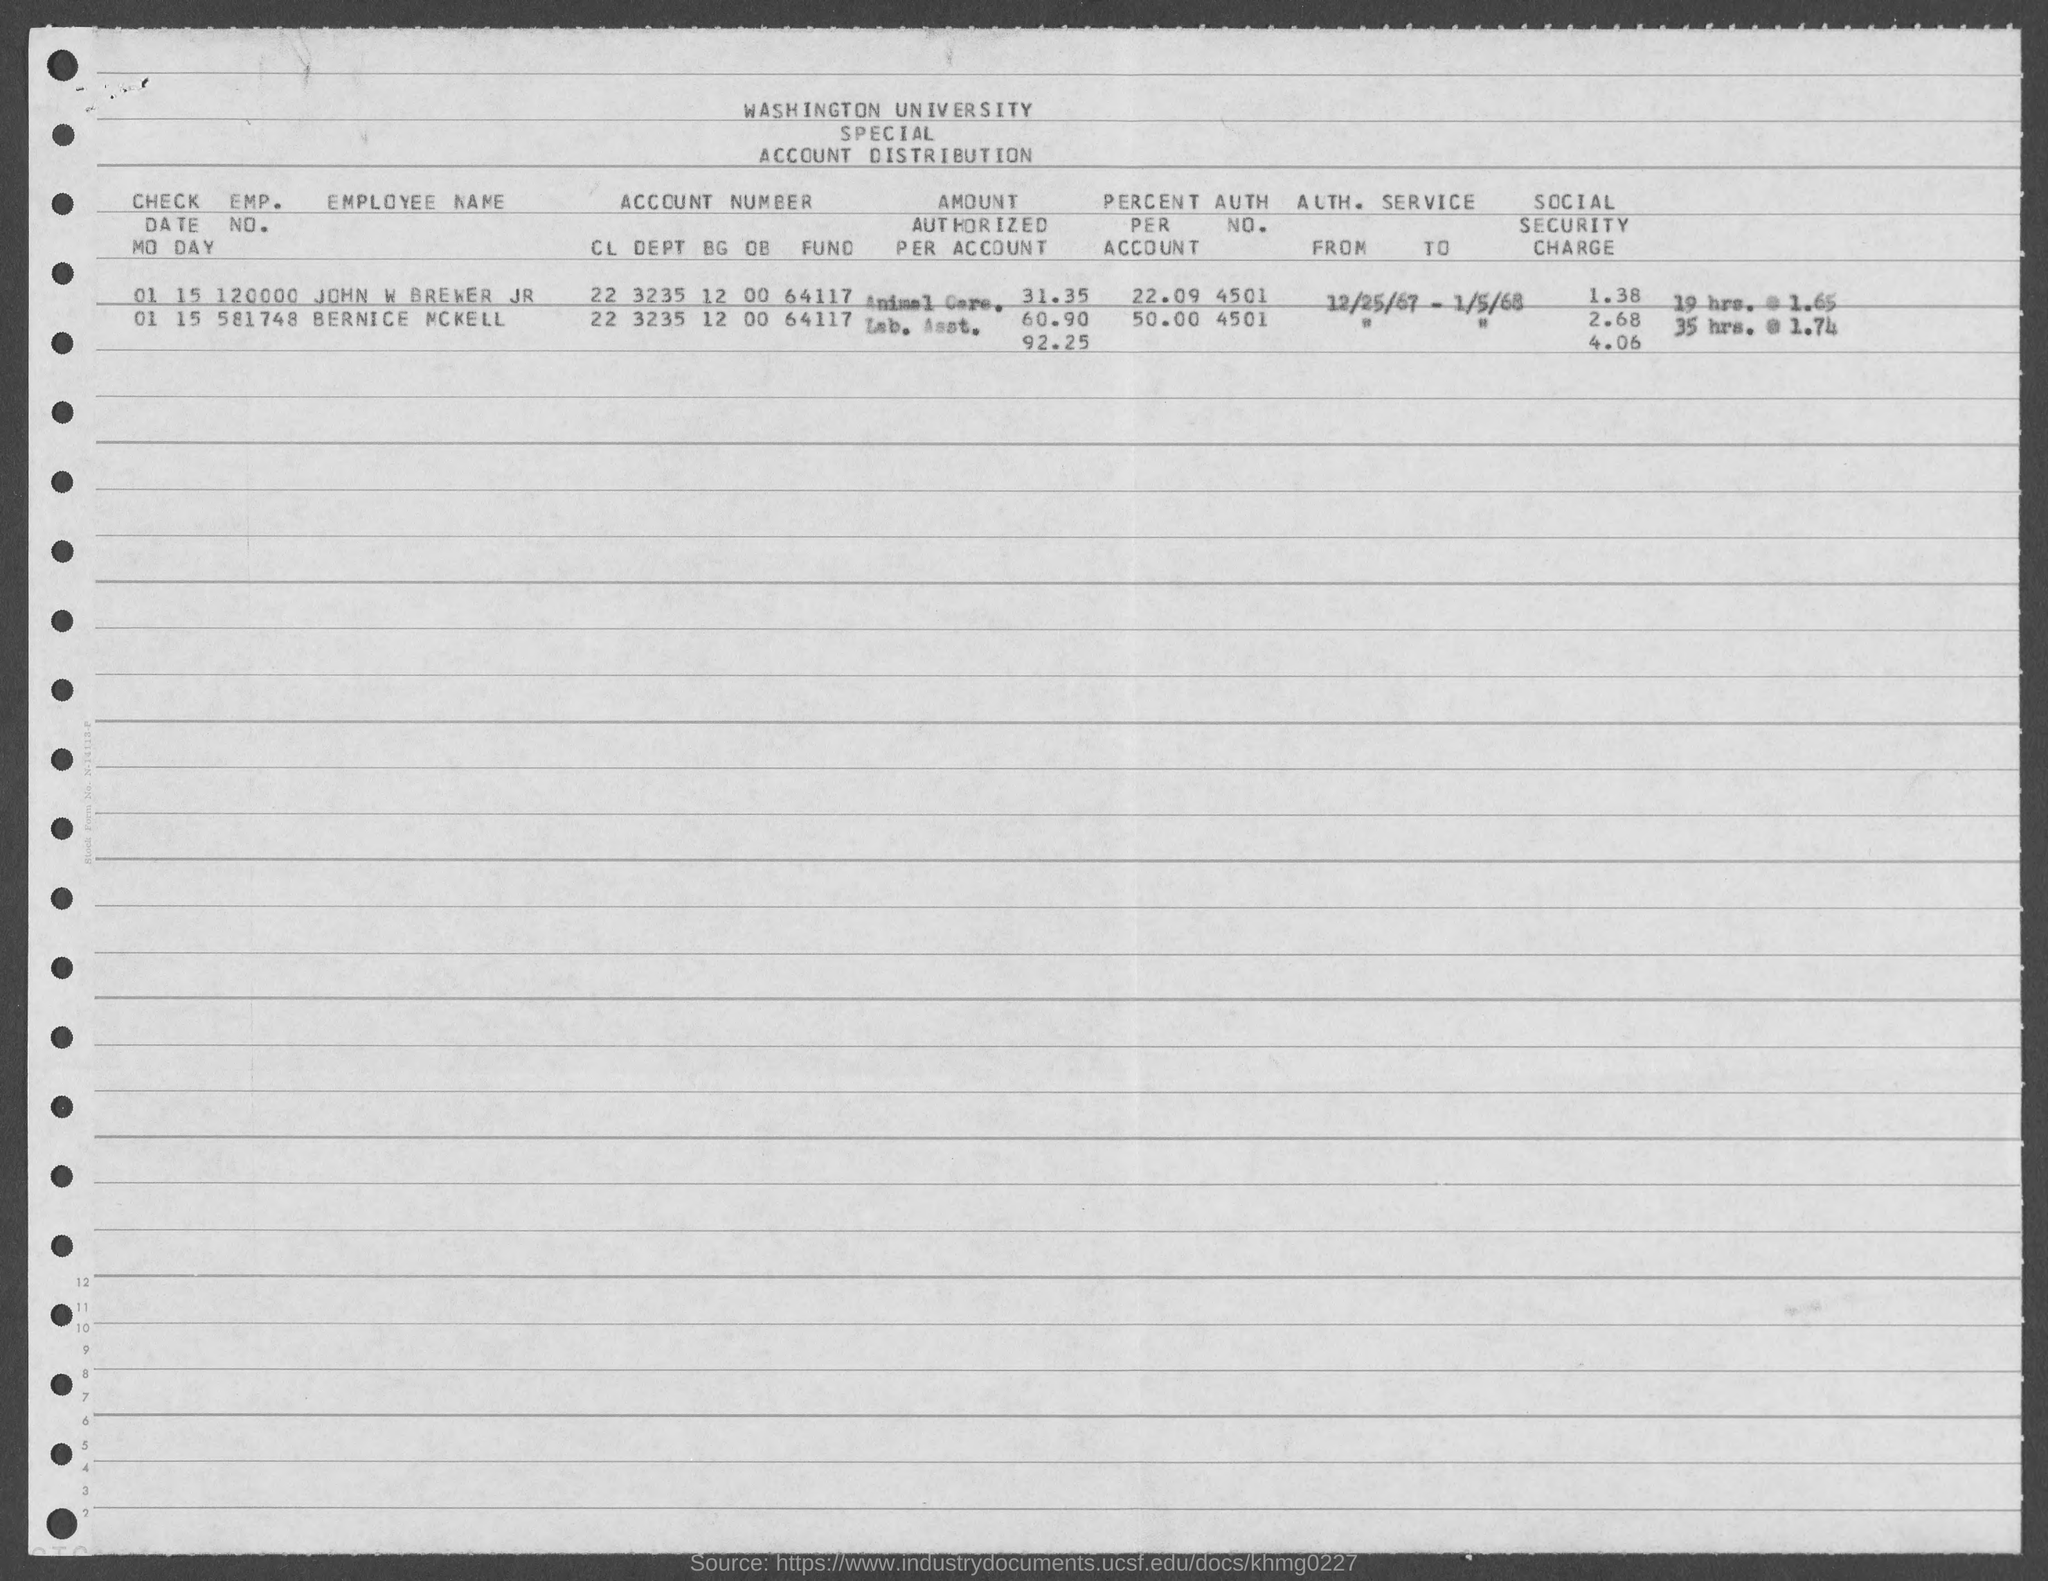What is the account number of john w brewer jr as mentioned in the given page ?
Give a very brief answer. 22 3235 12 00 64117. What is the account number of bernice mckell as mentioned in the given page ?
Provide a short and direct response. 22 3235 12 00 64117. What is the emp. no. of john w brewer as mentioned in the given page ?
Make the answer very short. 120000. What is the emp. no. of bernice mckell as mentioned in the given form ?
Offer a terse response. 581748. 